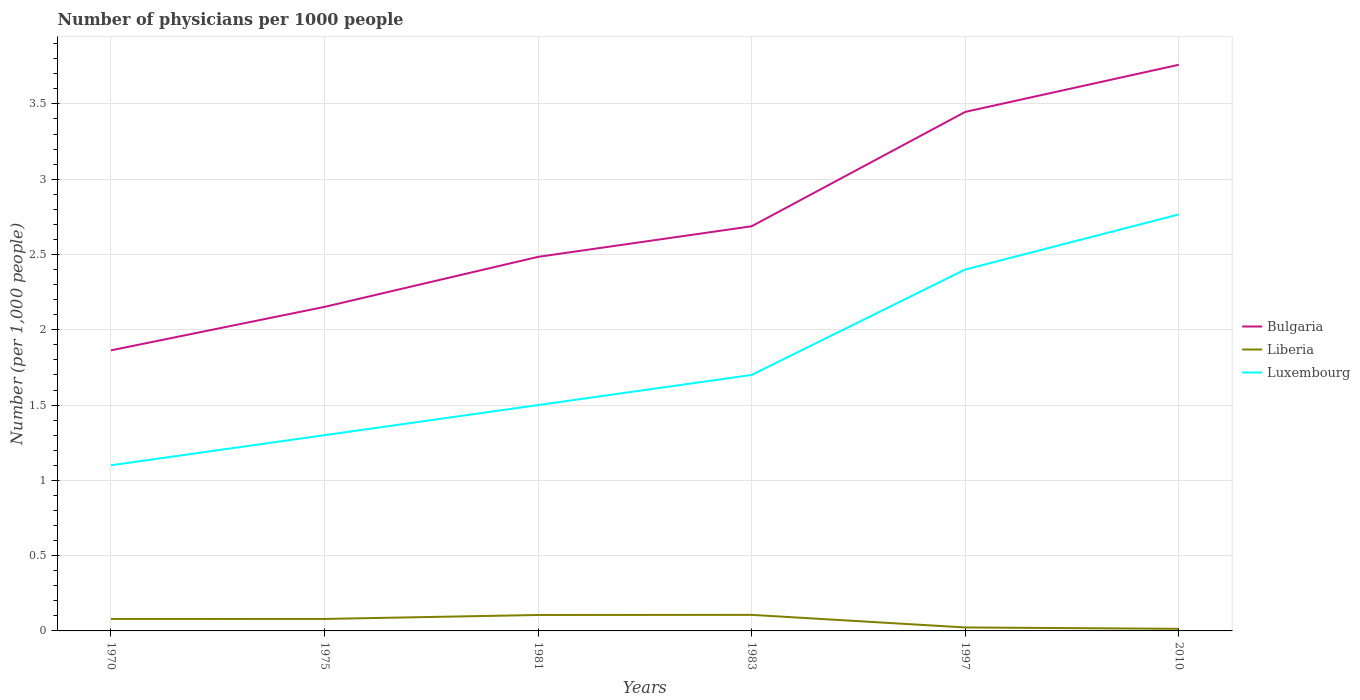How many different coloured lines are there?
Keep it short and to the point. 3. Is the number of lines equal to the number of legend labels?
Your response must be concise. Yes. Across all years, what is the maximum number of physicians in Liberia?
Provide a short and direct response. 0.01. What is the total number of physicians in Luxembourg in the graph?
Offer a terse response. -1.1. What is the difference between the highest and the second highest number of physicians in Luxembourg?
Give a very brief answer. 1.67. Is the number of physicians in Bulgaria strictly greater than the number of physicians in Liberia over the years?
Make the answer very short. No. How many lines are there?
Provide a short and direct response. 3. What is the difference between two consecutive major ticks on the Y-axis?
Your answer should be compact. 0.5. Are the values on the major ticks of Y-axis written in scientific E-notation?
Offer a terse response. No. Does the graph contain any zero values?
Your response must be concise. No. Does the graph contain grids?
Your response must be concise. Yes. How many legend labels are there?
Provide a succinct answer. 3. How are the legend labels stacked?
Your response must be concise. Vertical. What is the title of the graph?
Make the answer very short. Number of physicians per 1000 people. What is the label or title of the X-axis?
Keep it short and to the point. Years. What is the label or title of the Y-axis?
Provide a succinct answer. Number (per 1,0 people). What is the Number (per 1,000 people) in Bulgaria in 1970?
Ensure brevity in your answer.  1.86. What is the Number (per 1,000 people) in Liberia in 1970?
Your answer should be very brief. 0.08. What is the Number (per 1,000 people) in Bulgaria in 1975?
Make the answer very short. 2.15. What is the Number (per 1,000 people) in Liberia in 1975?
Your response must be concise. 0.08. What is the Number (per 1,000 people) of Bulgaria in 1981?
Make the answer very short. 2.48. What is the Number (per 1,000 people) in Liberia in 1981?
Your response must be concise. 0.11. What is the Number (per 1,000 people) of Bulgaria in 1983?
Ensure brevity in your answer.  2.69. What is the Number (per 1,000 people) of Liberia in 1983?
Your answer should be very brief. 0.11. What is the Number (per 1,000 people) in Luxembourg in 1983?
Keep it short and to the point. 1.7. What is the Number (per 1,000 people) in Bulgaria in 1997?
Your response must be concise. 3.45. What is the Number (per 1,000 people) of Liberia in 1997?
Give a very brief answer. 0.02. What is the Number (per 1,000 people) of Luxembourg in 1997?
Your response must be concise. 2.4. What is the Number (per 1,000 people) of Bulgaria in 2010?
Make the answer very short. 3.76. What is the Number (per 1,000 people) in Liberia in 2010?
Provide a short and direct response. 0.01. What is the Number (per 1,000 people) of Luxembourg in 2010?
Your answer should be compact. 2.77. Across all years, what is the maximum Number (per 1,000 people) of Bulgaria?
Offer a very short reply. 3.76. Across all years, what is the maximum Number (per 1,000 people) of Liberia?
Your answer should be very brief. 0.11. Across all years, what is the maximum Number (per 1,000 people) of Luxembourg?
Provide a succinct answer. 2.77. Across all years, what is the minimum Number (per 1,000 people) of Bulgaria?
Make the answer very short. 1.86. Across all years, what is the minimum Number (per 1,000 people) of Liberia?
Your answer should be compact. 0.01. Across all years, what is the minimum Number (per 1,000 people) in Luxembourg?
Provide a short and direct response. 1.1. What is the total Number (per 1,000 people) of Bulgaria in the graph?
Keep it short and to the point. 16.39. What is the total Number (per 1,000 people) of Liberia in the graph?
Give a very brief answer. 0.41. What is the total Number (per 1,000 people) in Luxembourg in the graph?
Keep it short and to the point. 10.77. What is the difference between the Number (per 1,000 people) of Bulgaria in 1970 and that in 1975?
Offer a very short reply. -0.29. What is the difference between the Number (per 1,000 people) of Liberia in 1970 and that in 1975?
Offer a terse response. -0. What is the difference between the Number (per 1,000 people) in Luxembourg in 1970 and that in 1975?
Give a very brief answer. -0.2. What is the difference between the Number (per 1,000 people) of Bulgaria in 1970 and that in 1981?
Provide a succinct answer. -0.62. What is the difference between the Number (per 1,000 people) of Liberia in 1970 and that in 1981?
Your answer should be compact. -0.03. What is the difference between the Number (per 1,000 people) in Bulgaria in 1970 and that in 1983?
Keep it short and to the point. -0.82. What is the difference between the Number (per 1,000 people) in Liberia in 1970 and that in 1983?
Give a very brief answer. -0.03. What is the difference between the Number (per 1,000 people) in Luxembourg in 1970 and that in 1983?
Ensure brevity in your answer.  -0.6. What is the difference between the Number (per 1,000 people) of Bulgaria in 1970 and that in 1997?
Your answer should be very brief. -1.58. What is the difference between the Number (per 1,000 people) of Liberia in 1970 and that in 1997?
Your response must be concise. 0.06. What is the difference between the Number (per 1,000 people) in Luxembourg in 1970 and that in 1997?
Keep it short and to the point. -1.3. What is the difference between the Number (per 1,000 people) of Bulgaria in 1970 and that in 2010?
Make the answer very short. -1.9. What is the difference between the Number (per 1,000 people) in Liberia in 1970 and that in 2010?
Your answer should be very brief. 0.07. What is the difference between the Number (per 1,000 people) in Luxembourg in 1970 and that in 2010?
Your answer should be very brief. -1.67. What is the difference between the Number (per 1,000 people) in Bulgaria in 1975 and that in 1981?
Offer a terse response. -0.33. What is the difference between the Number (per 1,000 people) in Liberia in 1975 and that in 1981?
Your response must be concise. -0.03. What is the difference between the Number (per 1,000 people) in Luxembourg in 1975 and that in 1981?
Ensure brevity in your answer.  -0.2. What is the difference between the Number (per 1,000 people) in Bulgaria in 1975 and that in 1983?
Give a very brief answer. -0.54. What is the difference between the Number (per 1,000 people) in Liberia in 1975 and that in 1983?
Your response must be concise. -0.03. What is the difference between the Number (per 1,000 people) of Bulgaria in 1975 and that in 1997?
Your answer should be very brief. -1.29. What is the difference between the Number (per 1,000 people) in Liberia in 1975 and that in 1997?
Provide a succinct answer. 0.06. What is the difference between the Number (per 1,000 people) of Bulgaria in 1975 and that in 2010?
Provide a short and direct response. -1.61. What is the difference between the Number (per 1,000 people) in Liberia in 1975 and that in 2010?
Offer a very short reply. 0.07. What is the difference between the Number (per 1,000 people) of Luxembourg in 1975 and that in 2010?
Give a very brief answer. -1.47. What is the difference between the Number (per 1,000 people) in Bulgaria in 1981 and that in 1983?
Your answer should be compact. -0.2. What is the difference between the Number (per 1,000 people) of Liberia in 1981 and that in 1983?
Offer a terse response. -0. What is the difference between the Number (per 1,000 people) of Luxembourg in 1981 and that in 1983?
Provide a short and direct response. -0.2. What is the difference between the Number (per 1,000 people) in Bulgaria in 1981 and that in 1997?
Make the answer very short. -0.96. What is the difference between the Number (per 1,000 people) in Liberia in 1981 and that in 1997?
Keep it short and to the point. 0.08. What is the difference between the Number (per 1,000 people) of Luxembourg in 1981 and that in 1997?
Provide a short and direct response. -0.9. What is the difference between the Number (per 1,000 people) of Bulgaria in 1981 and that in 2010?
Offer a terse response. -1.28. What is the difference between the Number (per 1,000 people) in Liberia in 1981 and that in 2010?
Your answer should be compact. 0.09. What is the difference between the Number (per 1,000 people) of Luxembourg in 1981 and that in 2010?
Make the answer very short. -1.27. What is the difference between the Number (per 1,000 people) of Bulgaria in 1983 and that in 1997?
Provide a short and direct response. -0.76. What is the difference between the Number (per 1,000 people) in Liberia in 1983 and that in 1997?
Offer a terse response. 0.08. What is the difference between the Number (per 1,000 people) in Luxembourg in 1983 and that in 1997?
Provide a succinct answer. -0.7. What is the difference between the Number (per 1,000 people) in Bulgaria in 1983 and that in 2010?
Your response must be concise. -1.07. What is the difference between the Number (per 1,000 people) of Liberia in 1983 and that in 2010?
Offer a terse response. 0.09. What is the difference between the Number (per 1,000 people) in Luxembourg in 1983 and that in 2010?
Provide a short and direct response. -1.07. What is the difference between the Number (per 1,000 people) in Bulgaria in 1997 and that in 2010?
Make the answer very short. -0.31. What is the difference between the Number (per 1,000 people) in Liberia in 1997 and that in 2010?
Provide a succinct answer. 0.01. What is the difference between the Number (per 1,000 people) in Luxembourg in 1997 and that in 2010?
Offer a very short reply. -0.37. What is the difference between the Number (per 1,000 people) of Bulgaria in 1970 and the Number (per 1,000 people) of Liberia in 1975?
Your response must be concise. 1.78. What is the difference between the Number (per 1,000 people) in Bulgaria in 1970 and the Number (per 1,000 people) in Luxembourg in 1975?
Offer a very short reply. 0.56. What is the difference between the Number (per 1,000 people) in Liberia in 1970 and the Number (per 1,000 people) in Luxembourg in 1975?
Provide a short and direct response. -1.22. What is the difference between the Number (per 1,000 people) of Bulgaria in 1970 and the Number (per 1,000 people) of Liberia in 1981?
Make the answer very short. 1.76. What is the difference between the Number (per 1,000 people) of Bulgaria in 1970 and the Number (per 1,000 people) of Luxembourg in 1981?
Make the answer very short. 0.36. What is the difference between the Number (per 1,000 people) in Liberia in 1970 and the Number (per 1,000 people) in Luxembourg in 1981?
Give a very brief answer. -1.42. What is the difference between the Number (per 1,000 people) in Bulgaria in 1970 and the Number (per 1,000 people) in Liberia in 1983?
Your answer should be compact. 1.76. What is the difference between the Number (per 1,000 people) in Bulgaria in 1970 and the Number (per 1,000 people) in Luxembourg in 1983?
Provide a succinct answer. 0.16. What is the difference between the Number (per 1,000 people) of Liberia in 1970 and the Number (per 1,000 people) of Luxembourg in 1983?
Your response must be concise. -1.62. What is the difference between the Number (per 1,000 people) of Bulgaria in 1970 and the Number (per 1,000 people) of Liberia in 1997?
Provide a short and direct response. 1.84. What is the difference between the Number (per 1,000 people) of Bulgaria in 1970 and the Number (per 1,000 people) of Luxembourg in 1997?
Make the answer very short. -0.54. What is the difference between the Number (per 1,000 people) in Liberia in 1970 and the Number (per 1,000 people) in Luxembourg in 1997?
Offer a very short reply. -2.32. What is the difference between the Number (per 1,000 people) of Bulgaria in 1970 and the Number (per 1,000 people) of Liberia in 2010?
Ensure brevity in your answer.  1.85. What is the difference between the Number (per 1,000 people) of Bulgaria in 1970 and the Number (per 1,000 people) of Luxembourg in 2010?
Keep it short and to the point. -0.9. What is the difference between the Number (per 1,000 people) in Liberia in 1970 and the Number (per 1,000 people) in Luxembourg in 2010?
Offer a very short reply. -2.69. What is the difference between the Number (per 1,000 people) of Bulgaria in 1975 and the Number (per 1,000 people) of Liberia in 1981?
Give a very brief answer. 2.05. What is the difference between the Number (per 1,000 people) of Bulgaria in 1975 and the Number (per 1,000 people) of Luxembourg in 1981?
Provide a succinct answer. 0.65. What is the difference between the Number (per 1,000 people) of Liberia in 1975 and the Number (per 1,000 people) of Luxembourg in 1981?
Offer a very short reply. -1.42. What is the difference between the Number (per 1,000 people) in Bulgaria in 1975 and the Number (per 1,000 people) in Liberia in 1983?
Offer a very short reply. 2.05. What is the difference between the Number (per 1,000 people) in Bulgaria in 1975 and the Number (per 1,000 people) in Luxembourg in 1983?
Provide a short and direct response. 0.45. What is the difference between the Number (per 1,000 people) of Liberia in 1975 and the Number (per 1,000 people) of Luxembourg in 1983?
Offer a very short reply. -1.62. What is the difference between the Number (per 1,000 people) in Bulgaria in 1975 and the Number (per 1,000 people) in Liberia in 1997?
Offer a terse response. 2.13. What is the difference between the Number (per 1,000 people) of Bulgaria in 1975 and the Number (per 1,000 people) of Luxembourg in 1997?
Your answer should be very brief. -0.25. What is the difference between the Number (per 1,000 people) of Liberia in 1975 and the Number (per 1,000 people) of Luxembourg in 1997?
Your response must be concise. -2.32. What is the difference between the Number (per 1,000 people) in Bulgaria in 1975 and the Number (per 1,000 people) in Liberia in 2010?
Ensure brevity in your answer.  2.14. What is the difference between the Number (per 1,000 people) in Bulgaria in 1975 and the Number (per 1,000 people) in Luxembourg in 2010?
Your response must be concise. -0.61. What is the difference between the Number (per 1,000 people) of Liberia in 1975 and the Number (per 1,000 people) of Luxembourg in 2010?
Your answer should be compact. -2.69. What is the difference between the Number (per 1,000 people) in Bulgaria in 1981 and the Number (per 1,000 people) in Liberia in 1983?
Your response must be concise. 2.38. What is the difference between the Number (per 1,000 people) of Bulgaria in 1981 and the Number (per 1,000 people) of Luxembourg in 1983?
Ensure brevity in your answer.  0.78. What is the difference between the Number (per 1,000 people) of Liberia in 1981 and the Number (per 1,000 people) of Luxembourg in 1983?
Give a very brief answer. -1.59. What is the difference between the Number (per 1,000 people) in Bulgaria in 1981 and the Number (per 1,000 people) in Liberia in 1997?
Offer a very short reply. 2.46. What is the difference between the Number (per 1,000 people) in Bulgaria in 1981 and the Number (per 1,000 people) in Luxembourg in 1997?
Your answer should be very brief. 0.08. What is the difference between the Number (per 1,000 people) of Liberia in 1981 and the Number (per 1,000 people) of Luxembourg in 1997?
Provide a succinct answer. -2.29. What is the difference between the Number (per 1,000 people) in Bulgaria in 1981 and the Number (per 1,000 people) in Liberia in 2010?
Provide a succinct answer. 2.47. What is the difference between the Number (per 1,000 people) of Bulgaria in 1981 and the Number (per 1,000 people) of Luxembourg in 2010?
Offer a terse response. -0.28. What is the difference between the Number (per 1,000 people) in Liberia in 1981 and the Number (per 1,000 people) in Luxembourg in 2010?
Make the answer very short. -2.66. What is the difference between the Number (per 1,000 people) of Bulgaria in 1983 and the Number (per 1,000 people) of Liberia in 1997?
Keep it short and to the point. 2.66. What is the difference between the Number (per 1,000 people) of Bulgaria in 1983 and the Number (per 1,000 people) of Luxembourg in 1997?
Your response must be concise. 0.29. What is the difference between the Number (per 1,000 people) of Liberia in 1983 and the Number (per 1,000 people) of Luxembourg in 1997?
Offer a terse response. -2.29. What is the difference between the Number (per 1,000 people) in Bulgaria in 1983 and the Number (per 1,000 people) in Liberia in 2010?
Give a very brief answer. 2.67. What is the difference between the Number (per 1,000 people) in Bulgaria in 1983 and the Number (per 1,000 people) in Luxembourg in 2010?
Offer a terse response. -0.08. What is the difference between the Number (per 1,000 people) of Liberia in 1983 and the Number (per 1,000 people) of Luxembourg in 2010?
Provide a short and direct response. -2.66. What is the difference between the Number (per 1,000 people) in Bulgaria in 1997 and the Number (per 1,000 people) in Liberia in 2010?
Ensure brevity in your answer.  3.43. What is the difference between the Number (per 1,000 people) in Bulgaria in 1997 and the Number (per 1,000 people) in Luxembourg in 2010?
Provide a succinct answer. 0.68. What is the difference between the Number (per 1,000 people) of Liberia in 1997 and the Number (per 1,000 people) of Luxembourg in 2010?
Your answer should be compact. -2.74. What is the average Number (per 1,000 people) of Bulgaria per year?
Give a very brief answer. 2.73. What is the average Number (per 1,000 people) in Liberia per year?
Your answer should be very brief. 0.07. What is the average Number (per 1,000 people) in Luxembourg per year?
Your answer should be very brief. 1.79. In the year 1970, what is the difference between the Number (per 1,000 people) in Bulgaria and Number (per 1,000 people) in Liberia?
Ensure brevity in your answer.  1.78. In the year 1970, what is the difference between the Number (per 1,000 people) of Bulgaria and Number (per 1,000 people) of Luxembourg?
Make the answer very short. 0.76. In the year 1970, what is the difference between the Number (per 1,000 people) in Liberia and Number (per 1,000 people) in Luxembourg?
Offer a terse response. -1.02. In the year 1975, what is the difference between the Number (per 1,000 people) in Bulgaria and Number (per 1,000 people) in Liberia?
Provide a short and direct response. 2.07. In the year 1975, what is the difference between the Number (per 1,000 people) of Bulgaria and Number (per 1,000 people) of Luxembourg?
Make the answer very short. 0.85. In the year 1975, what is the difference between the Number (per 1,000 people) in Liberia and Number (per 1,000 people) in Luxembourg?
Your answer should be very brief. -1.22. In the year 1981, what is the difference between the Number (per 1,000 people) of Bulgaria and Number (per 1,000 people) of Liberia?
Your response must be concise. 2.38. In the year 1981, what is the difference between the Number (per 1,000 people) in Bulgaria and Number (per 1,000 people) in Luxembourg?
Provide a short and direct response. 0.98. In the year 1981, what is the difference between the Number (per 1,000 people) in Liberia and Number (per 1,000 people) in Luxembourg?
Provide a succinct answer. -1.39. In the year 1983, what is the difference between the Number (per 1,000 people) in Bulgaria and Number (per 1,000 people) in Liberia?
Your answer should be very brief. 2.58. In the year 1983, what is the difference between the Number (per 1,000 people) in Bulgaria and Number (per 1,000 people) in Luxembourg?
Offer a terse response. 0.99. In the year 1983, what is the difference between the Number (per 1,000 people) in Liberia and Number (per 1,000 people) in Luxembourg?
Your answer should be compact. -1.59. In the year 1997, what is the difference between the Number (per 1,000 people) in Bulgaria and Number (per 1,000 people) in Liberia?
Offer a terse response. 3.42. In the year 1997, what is the difference between the Number (per 1,000 people) in Bulgaria and Number (per 1,000 people) in Luxembourg?
Make the answer very short. 1.05. In the year 1997, what is the difference between the Number (per 1,000 people) of Liberia and Number (per 1,000 people) of Luxembourg?
Ensure brevity in your answer.  -2.38. In the year 2010, what is the difference between the Number (per 1,000 people) of Bulgaria and Number (per 1,000 people) of Liberia?
Ensure brevity in your answer.  3.75. In the year 2010, what is the difference between the Number (per 1,000 people) of Liberia and Number (per 1,000 people) of Luxembourg?
Make the answer very short. -2.75. What is the ratio of the Number (per 1,000 people) of Bulgaria in 1970 to that in 1975?
Provide a succinct answer. 0.87. What is the ratio of the Number (per 1,000 people) in Luxembourg in 1970 to that in 1975?
Give a very brief answer. 0.85. What is the ratio of the Number (per 1,000 people) in Liberia in 1970 to that in 1981?
Provide a succinct answer. 0.75. What is the ratio of the Number (per 1,000 people) of Luxembourg in 1970 to that in 1981?
Provide a short and direct response. 0.73. What is the ratio of the Number (per 1,000 people) in Bulgaria in 1970 to that in 1983?
Keep it short and to the point. 0.69. What is the ratio of the Number (per 1,000 people) in Liberia in 1970 to that in 1983?
Your answer should be compact. 0.74. What is the ratio of the Number (per 1,000 people) in Luxembourg in 1970 to that in 1983?
Keep it short and to the point. 0.65. What is the ratio of the Number (per 1,000 people) in Bulgaria in 1970 to that in 1997?
Keep it short and to the point. 0.54. What is the ratio of the Number (per 1,000 people) in Liberia in 1970 to that in 1997?
Offer a terse response. 3.45. What is the ratio of the Number (per 1,000 people) of Luxembourg in 1970 to that in 1997?
Your response must be concise. 0.46. What is the ratio of the Number (per 1,000 people) of Bulgaria in 1970 to that in 2010?
Provide a short and direct response. 0.5. What is the ratio of the Number (per 1,000 people) in Liberia in 1970 to that in 2010?
Your response must be concise. 5.67. What is the ratio of the Number (per 1,000 people) in Luxembourg in 1970 to that in 2010?
Provide a short and direct response. 0.4. What is the ratio of the Number (per 1,000 people) of Bulgaria in 1975 to that in 1981?
Provide a succinct answer. 0.87. What is the ratio of the Number (per 1,000 people) of Liberia in 1975 to that in 1981?
Your answer should be compact. 0.75. What is the ratio of the Number (per 1,000 people) in Luxembourg in 1975 to that in 1981?
Keep it short and to the point. 0.87. What is the ratio of the Number (per 1,000 people) of Bulgaria in 1975 to that in 1983?
Your response must be concise. 0.8. What is the ratio of the Number (per 1,000 people) in Liberia in 1975 to that in 1983?
Your response must be concise. 0.75. What is the ratio of the Number (per 1,000 people) in Luxembourg in 1975 to that in 1983?
Keep it short and to the point. 0.76. What is the ratio of the Number (per 1,000 people) in Bulgaria in 1975 to that in 1997?
Make the answer very short. 0.62. What is the ratio of the Number (per 1,000 people) of Liberia in 1975 to that in 1997?
Your response must be concise. 3.46. What is the ratio of the Number (per 1,000 people) in Luxembourg in 1975 to that in 1997?
Your answer should be very brief. 0.54. What is the ratio of the Number (per 1,000 people) in Bulgaria in 1975 to that in 2010?
Offer a very short reply. 0.57. What is the ratio of the Number (per 1,000 people) in Liberia in 1975 to that in 2010?
Give a very brief answer. 5.69. What is the ratio of the Number (per 1,000 people) of Luxembourg in 1975 to that in 2010?
Provide a short and direct response. 0.47. What is the ratio of the Number (per 1,000 people) of Bulgaria in 1981 to that in 1983?
Your answer should be very brief. 0.92. What is the ratio of the Number (per 1,000 people) in Liberia in 1981 to that in 1983?
Make the answer very short. 0.99. What is the ratio of the Number (per 1,000 people) of Luxembourg in 1981 to that in 1983?
Offer a terse response. 0.88. What is the ratio of the Number (per 1,000 people) of Bulgaria in 1981 to that in 1997?
Your answer should be very brief. 0.72. What is the ratio of the Number (per 1,000 people) of Liberia in 1981 to that in 1997?
Make the answer very short. 4.6. What is the ratio of the Number (per 1,000 people) in Luxembourg in 1981 to that in 1997?
Your answer should be very brief. 0.62. What is the ratio of the Number (per 1,000 people) in Bulgaria in 1981 to that in 2010?
Give a very brief answer. 0.66. What is the ratio of the Number (per 1,000 people) in Liberia in 1981 to that in 2010?
Provide a short and direct response. 7.56. What is the ratio of the Number (per 1,000 people) in Luxembourg in 1981 to that in 2010?
Ensure brevity in your answer.  0.54. What is the ratio of the Number (per 1,000 people) of Bulgaria in 1983 to that in 1997?
Your response must be concise. 0.78. What is the ratio of the Number (per 1,000 people) of Liberia in 1983 to that in 1997?
Your answer should be very brief. 4.64. What is the ratio of the Number (per 1,000 people) in Luxembourg in 1983 to that in 1997?
Keep it short and to the point. 0.71. What is the ratio of the Number (per 1,000 people) of Bulgaria in 1983 to that in 2010?
Your answer should be compact. 0.71. What is the ratio of the Number (per 1,000 people) in Liberia in 1983 to that in 2010?
Provide a succinct answer. 7.62. What is the ratio of the Number (per 1,000 people) of Luxembourg in 1983 to that in 2010?
Your response must be concise. 0.61. What is the ratio of the Number (per 1,000 people) of Bulgaria in 1997 to that in 2010?
Offer a terse response. 0.92. What is the ratio of the Number (per 1,000 people) in Liberia in 1997 to that in 2010?
Give a very brief answer. 1.64. What is the ratio of the Number (per 1,000 people) in Luxembourg in 1997 to that in 2010?
Offer a terse response. 0.87. What is the difference between the highest and the second highest Number (per 1,000 people) in Bulgaria?
Make the answer very short. 0.31. What is the difference between the highest and the second highest Number (per 1,000 people) in Liberia?
Keep it short and to the point. 0. What is the difference between the highest and the second highest Number (per 1,000 people) of Luxembourg?
Your answer should be very brief. 0.37. What is the difference between the highest and the lowest Number (per 1,000 people) of Bulgaria?
Your answer should be very brief. 1.9. What is the difference between the highest and the lowest Number (per 1,000 people) of Liberia?
Offer a very short reply. 0.09. What is the difference between the highest and the lowest Number (per 1,000 people) in Luxembourg?
Your response must be concise. 1.67. 